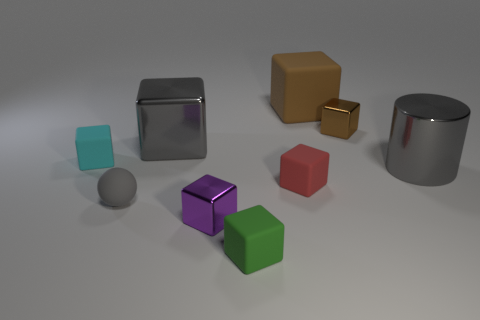Subtract all purple blocks. How many blocks are left? 6 Subtract all green cubes. How many cubes are left? 6 Subtract 3 cubes. How many cubes are left? 4 Add 1 cyan things. How many objects exist? 10 Subtract all green blocks. Subtract all green cylinders. How many blocks are left? 6 Subtract all blocks. How many objects are left? 2 Add 2 big gray rubber cylinders. How many big gray rubber cylinders exist? 2 Subtract 0 yellow cubes. How many objects are left? 9 Subtract all big red rubber balls. Subtract all brown shiny cubes. How many objects are left? 8 Add 2 green blocks. How many green blocks are left? 3 